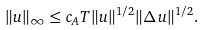<formula> <loc_0><loc_0><loc_500><loc_500>\| u \| _ { \infty } \leq c _ { A } T \| u \| ^ { 1 / 2 } \| \Delta \, u \| ^ { 1 / 2 } .</formula> 